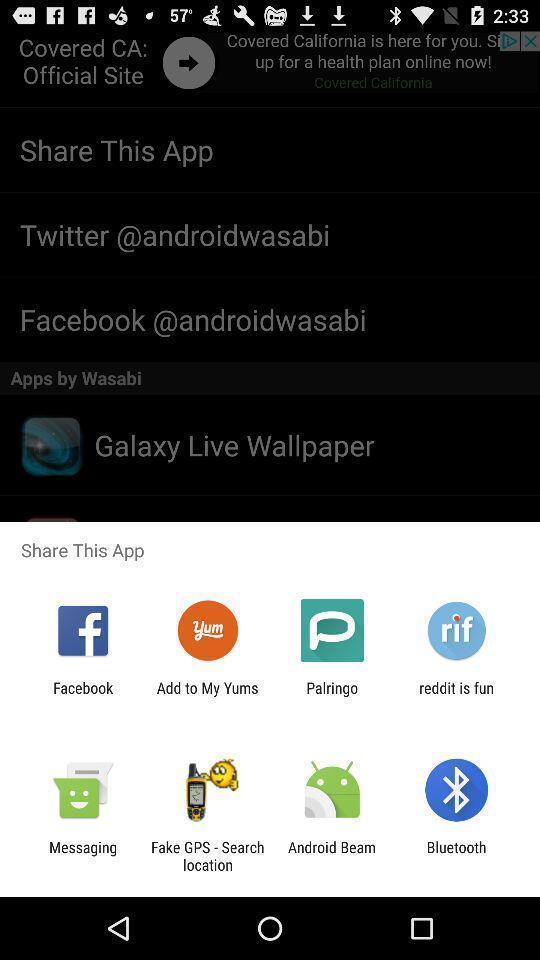Explain the elements present in this screenshot. Popup applications to share the app. 